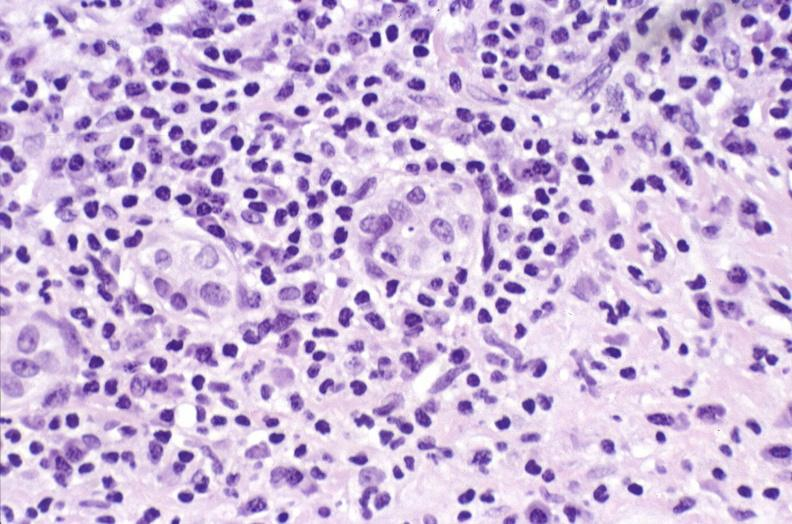does optic nerve show primary biliary cirrhosis?
Answer the question using a single word or phrase. No 